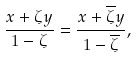Convert formula to latex. <formula><loc_0><loc_0><loc_500><loc_500>\frac { x + \zeta y } { 1 - \zeta } = \frac { x + \overline { \zeta } y } { 1 - \overline { \zeta } } ,</formula> 